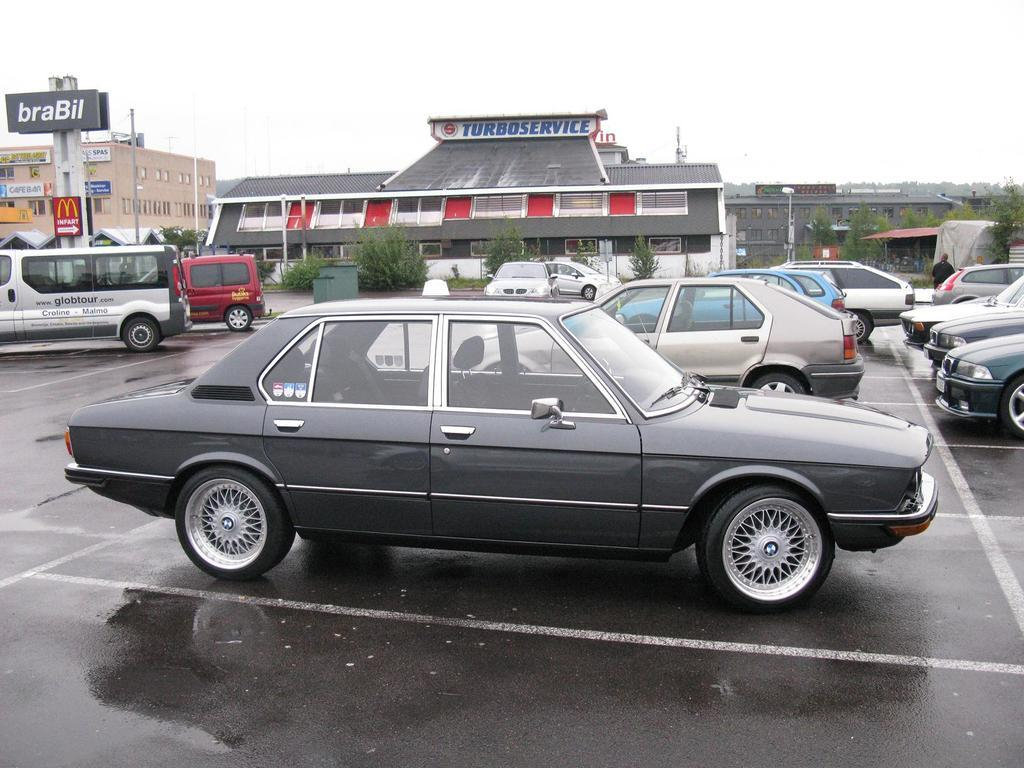What can be seen on the road in the image? There are cars on the road in the image. What is visible in the background of the image? There are houses, plants, and boards with text in the background of the image. What is visible at the top of the image? The sky is visible at the top of the image. How many fifths are present in the image? There is no mention of a "fifth" in the image, so it cannot be determined how many there are. What type of twig can be seen in the image? There is no twig present in the image. 